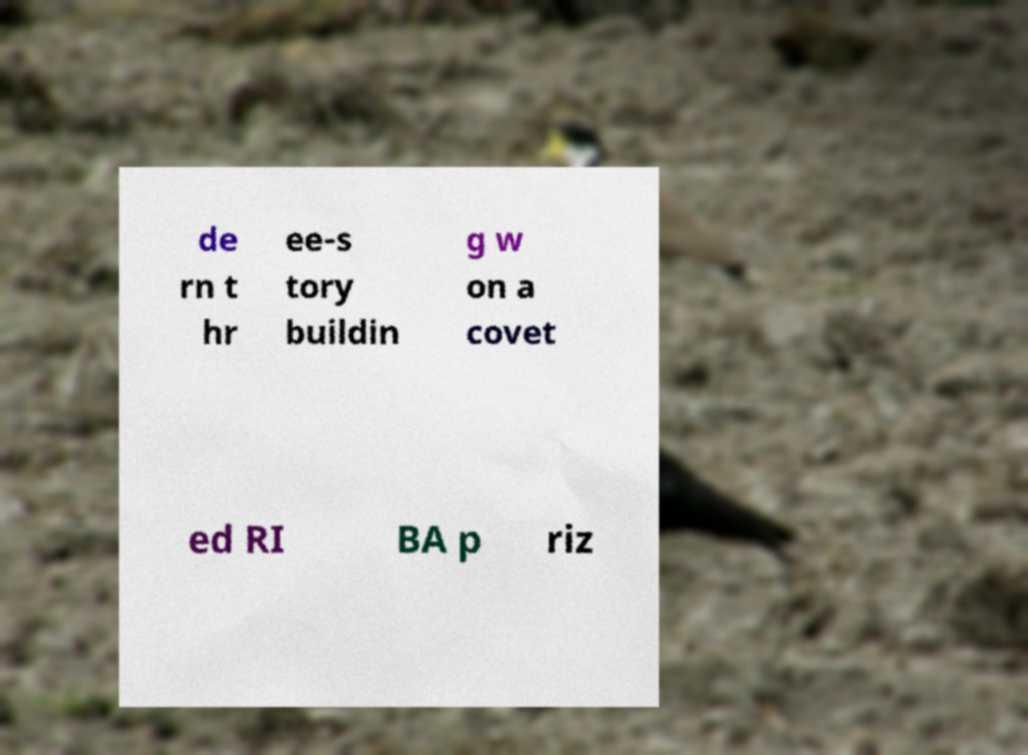For documentation purposes, I need the text within this image transcribed. Could you provide that? de rn t hr ee-s tory buildin g w on a covet ed RI BA p riz 